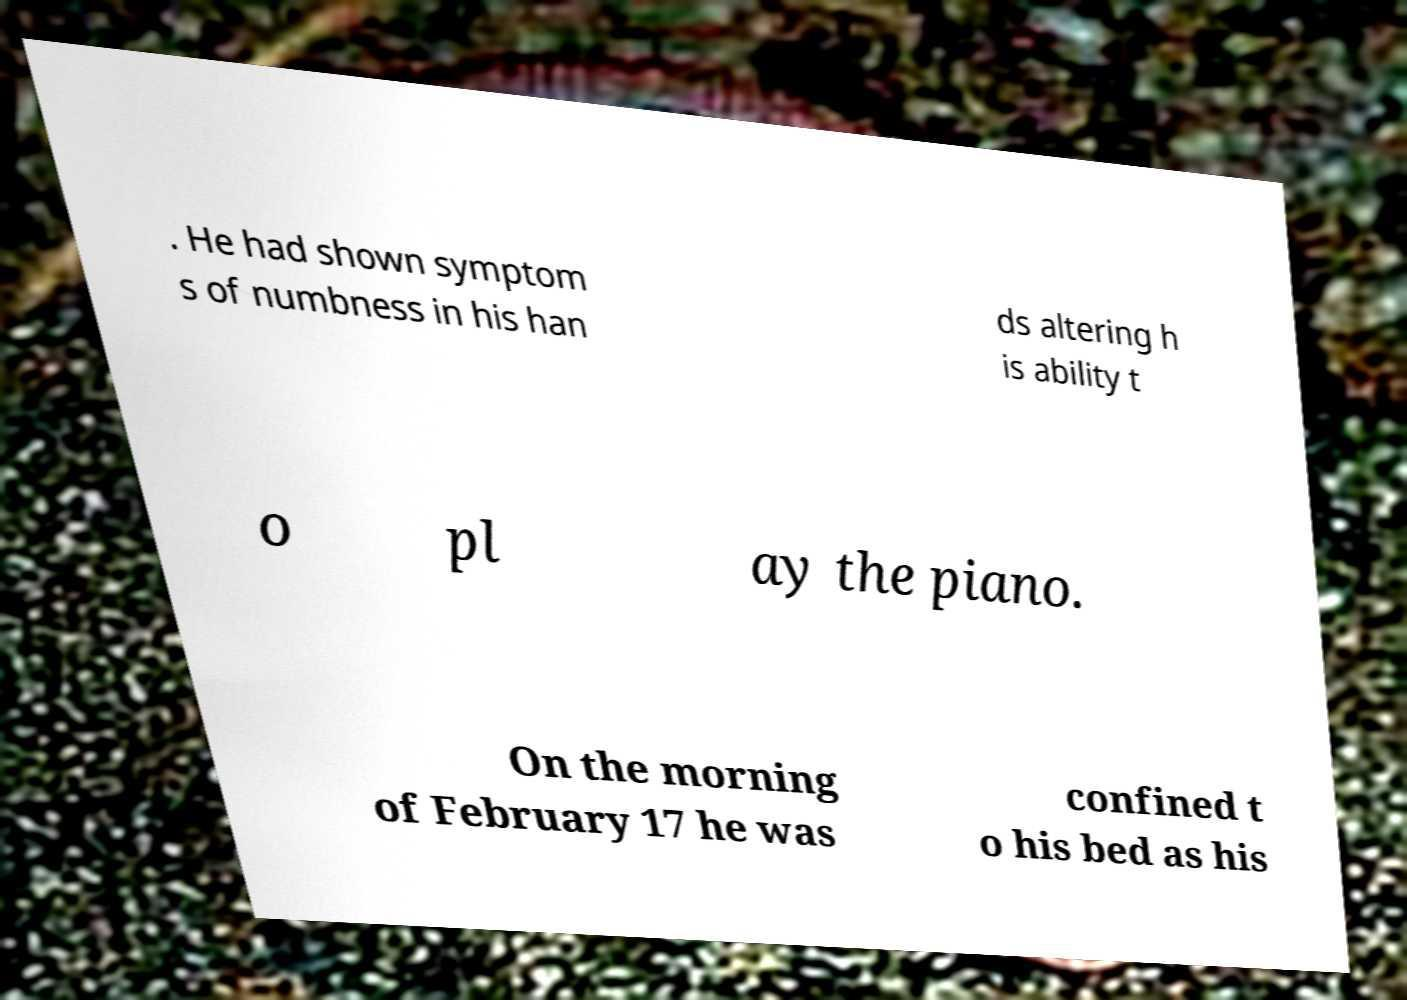Can you read and provide the text displayed in the image?This photo seems to have some interesting text. Can you extract and type it out for me? . He had shown symptom s of numbness in his han ds altering h is ability t o pl ay the piano. On the morning of February 17 he was confined t o his bed as his 